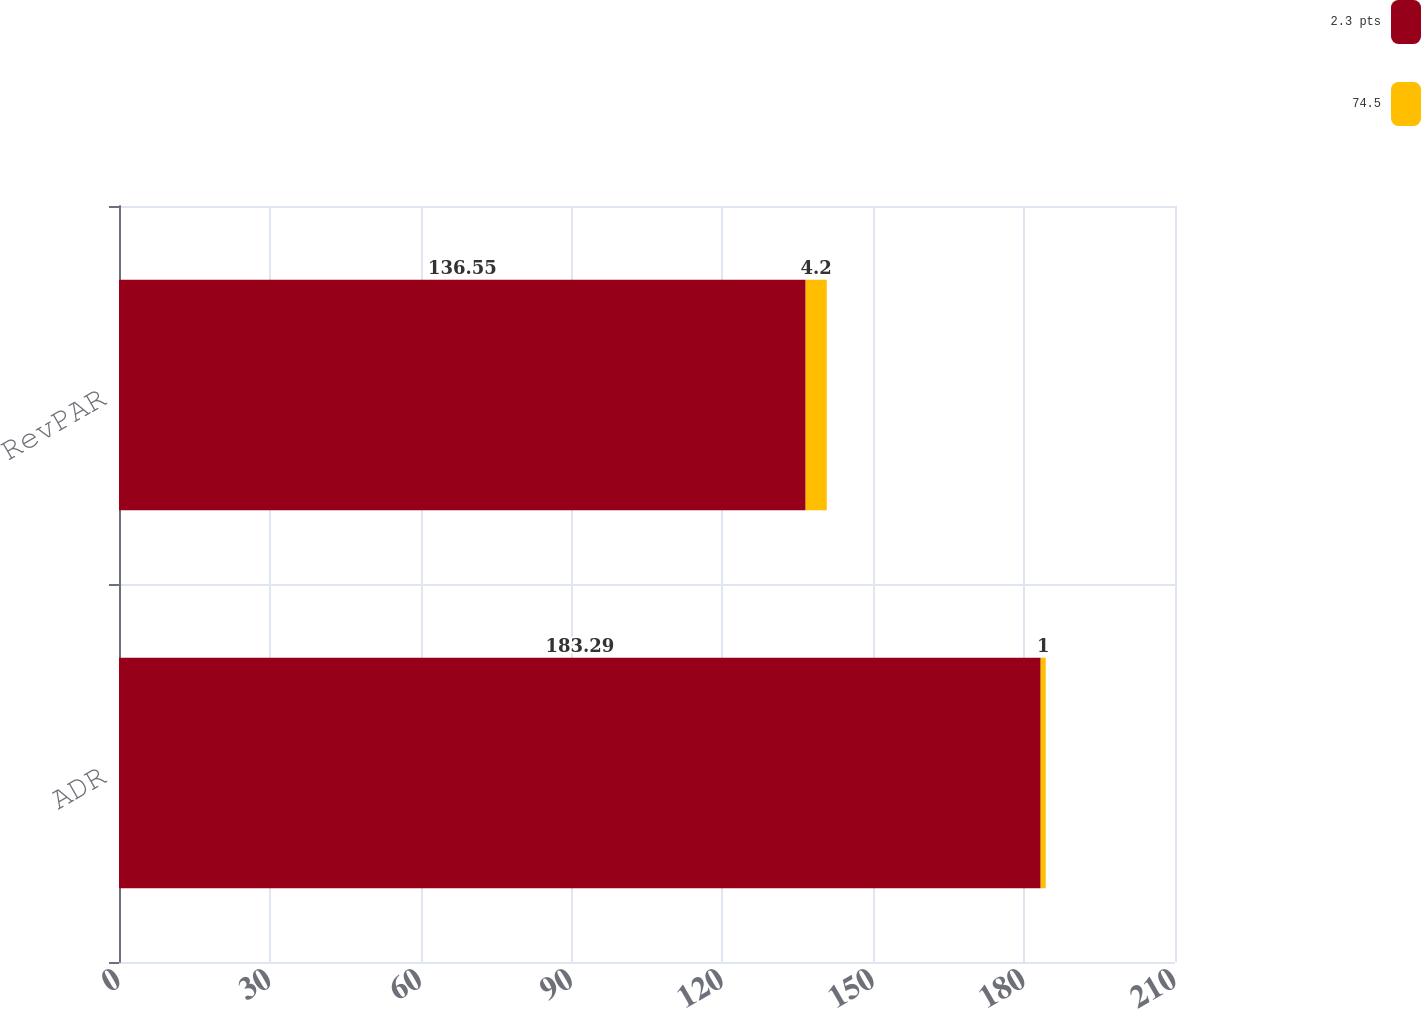Convert chart. <chart><loc_0><loc_0><loc_500><loc_500><stacked_bar_chart><ecel><fcel>ADR<fcel>RevPAR<nl><fcel>2.3 pts<fcel>183.29<fcel>136.55<nl><fcel>74.5<fcel>1<fcel>4.2<nl></chart> 